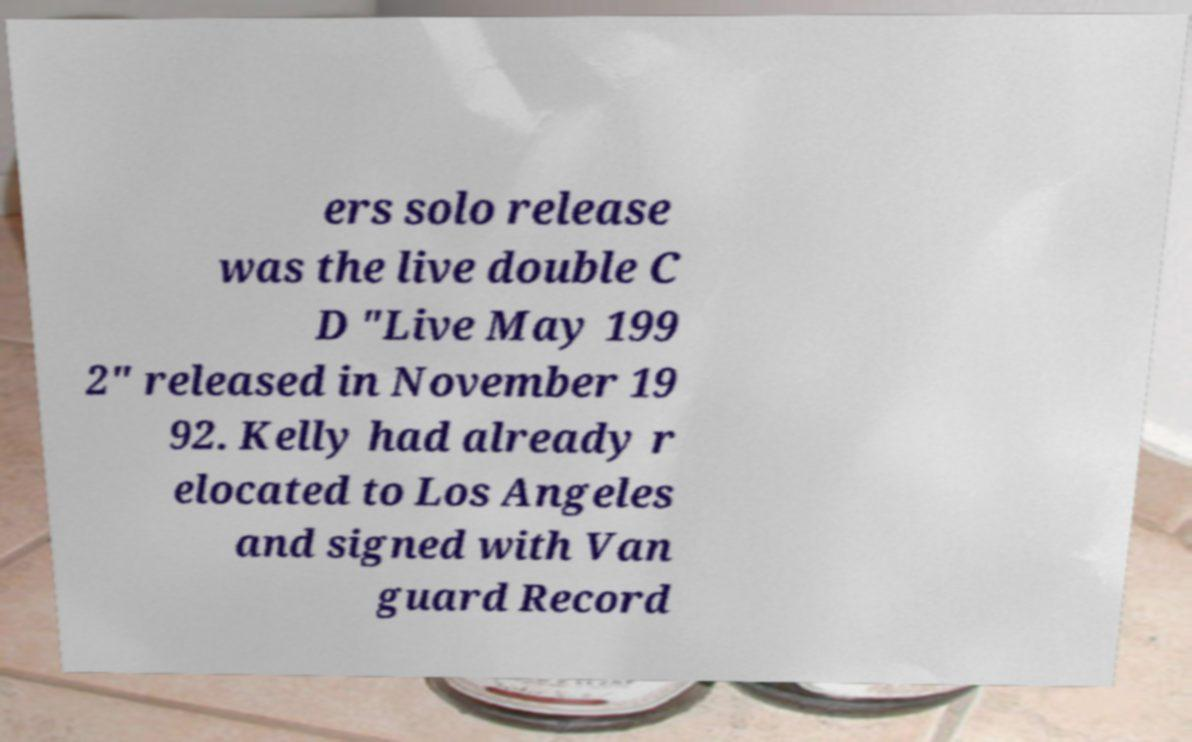What messages or text are displayed in this image? I need them in a readable, typed format. ers solo release was the live double C D "Live May 199 2" released in November 19 92. Kelly had already r elocated to Los Angeles and signed with Van guard Record 